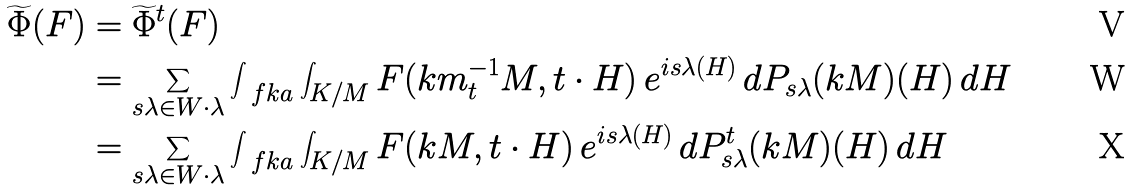Convert formula to latex. <formula><loc_0><loc_0><loc_500><loc_500>\widetilde { \Phi } ( F ) & = \widetilde { \Phi } ^ { t } ( F ) \\ & = \sum _ { s \lambda \in W \cdot \lambda } \int _ { \ f k a } \int _ { K / M } F ( k m _ { t } ^ { - 1 } M , t \cdot H ) \, e ^ { i s \lambda ( H ) } \, d P _ { s \lambda } ( k M ) ( H ) \, d H \\ & = \sum _ { s \lambda \in W \cdot \lambda } \int _ { \ f k a } \int _ { K / M } F ( k M , t \cdot H ) \, e ^ { i s \lambda ( H ) } \, d P _ { s \lambda } ^ { t } ( k M ) ( H ) \, d H</formula> 